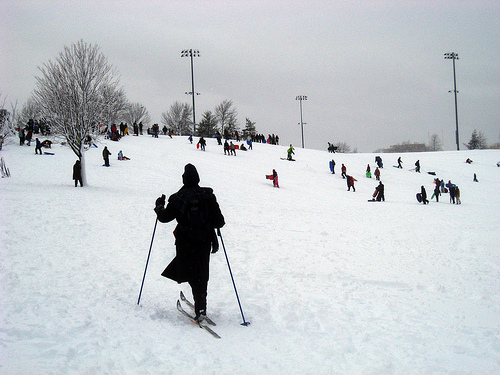Describe the overall atmosphere conveyed in the image. The image exudes a serene, yet invigorating atmosphere, with individuals of all ages engaging in winter sports on a snowy day. What activity are most people in the image engaged in? Most people in the image appear to be engaged in skiing or snowboarding, enjoying the snowy terrain. Could you describe the clothing and equipment people are using? Individuals are dressed in winter attire, including heavy coats, gloves, and wool caps. The majority are equipped with skiing gear such as skis, poles, and snowboards, ready to glide down the snowy slopes. Can you imagine a festive event happening in the sharegpt4v/same setting? Describe it in detail. Imagine a festive winter carnival unfolding in this snowy wonderland. Brightly colored banners and strings of fairy lights adorn the trees and light posts. A large, decorated Christmas tree stands at the center, surrounded by stalls selling hot chocolate, mulled wine, and festive treats. Children laugh and play, building snowmen and engaging in friendly snowball fights. A small stage has been set up for live performances, with singers and musicians entertaining the crowd. The air is filled with the aromas of warm food and the sound of joyous holiday music, creating a magical, festive atmosphere. 